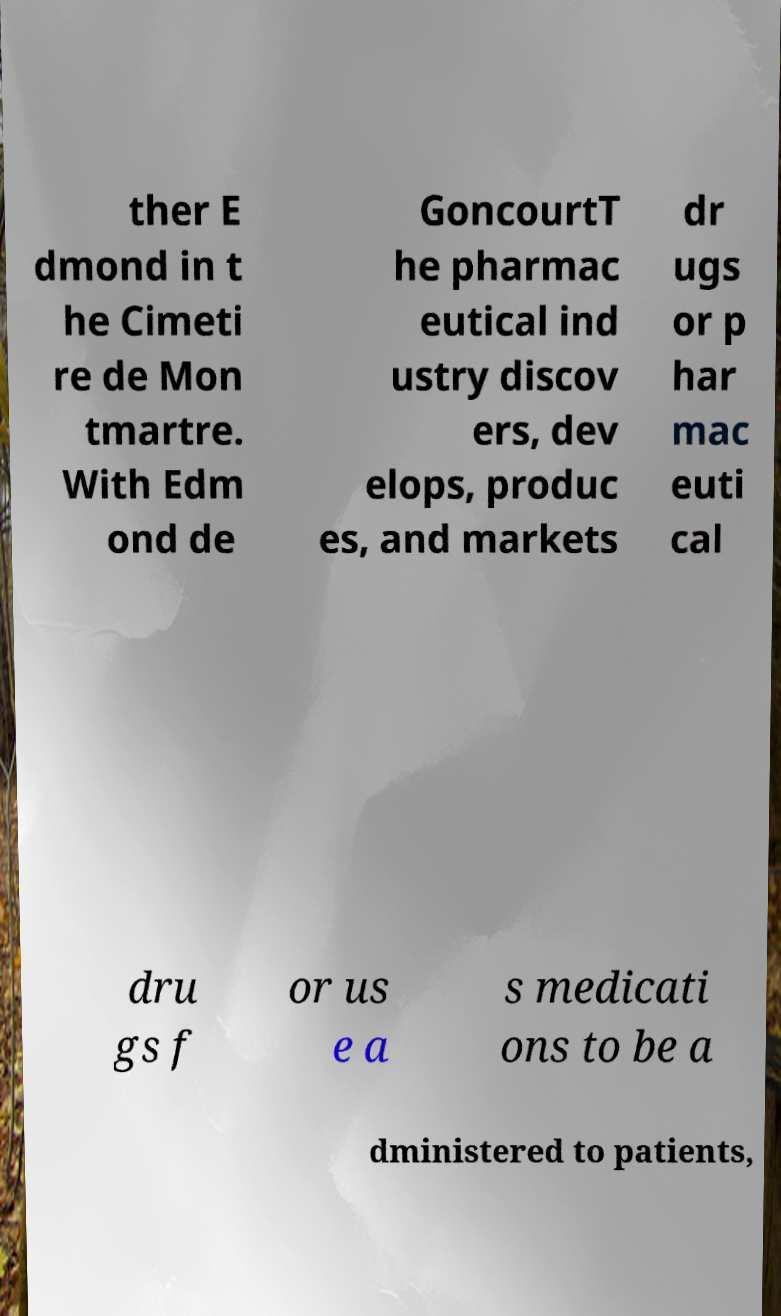Can you read and provide the text displayed in the image?This photo seems to have some interesting text. Can you extract and type it out for me? ther E dmond in t he Cimeti re de Mon tmartre. With Edm ond de GoncourtT he pharmac eutical ind ustry discov ers, dev elops, produc es, and markets dr ugs or p har mac euti cal dru gs f or us e a s medicati ons to be a dministered to patients, 